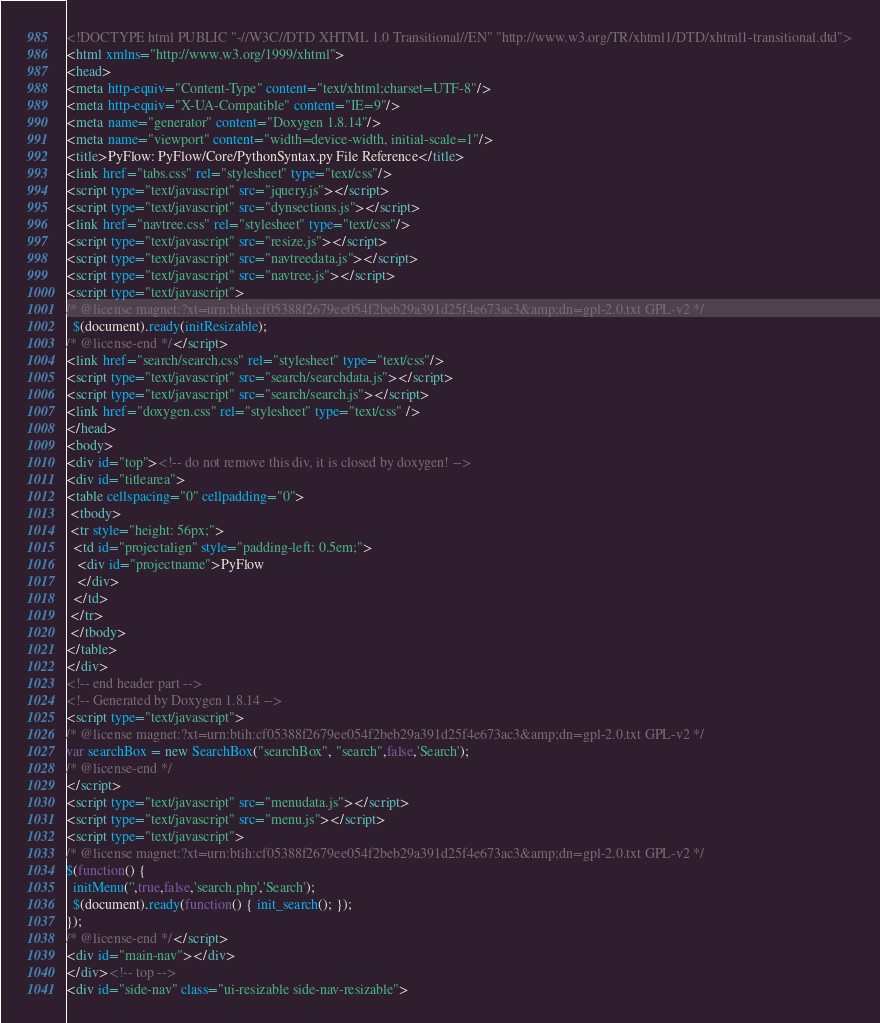<code> <loc_0><loc_0><loc_500><loc_500><_HTML_><!DOCTYPE html PUBLIC "-//W3C//DTD XHTML 1.0 Transitional//EN" "http://www.w3.org/TR/xhtml1/DTD/xhtml1-transitional.dtd">
<html xmlns="http://www.w3.org/1999/xhtml">
<head>
<meta http-equiv="Content-Type" content="text/xhtml;charset=UTF-8"/>
<meta http-equiv="X-UA-Compatible" content="IE=9"/>
<meta name="generator" content="Doxygen 1.8.14"/>
<meta name="viewport" content="width=device-width, initial-scale=1"/>
<title>PyFlow: PyFlow/Core/PythonSyntax.py File Reference</title>
<link href="tabs.css" rel="stylesheet" type="text/css"/>
<script type="text/javascript" src="jquery.js"></script>
<script type="text/javascript" src="dynsections.js"></script>
<link href="navtree.css" rel="stylesheet" type="text/css"/>
<script type="text/javascript" src="resize.js"></script>
<script type="text/javascript" src="navtreedata.js"></script>
<script type="text/javascript" src="navtree.js"></script>
<script type="text/javascript">
/* @license magnet:?xt=urn:btih:cf05388f2679ee054f2beb29a391d25f4e673ac3&amp;dn=gpl-2.0.txt GPL-v2 */
  $(document).ready(initResizable);
/* @license-end */</script>
<link href="search/search.css" rel="stylesheet" type="text/css"/>
<script type="text/javascript" src="search/searchdata.js"></script>
<script type="text/javascript" src="search/search.js"></script>
<link href="doxygen.css" rel="stylesheet" type="text/css" />
</head>
<body>
<div id="top"><!-- do not remove this div, it is closed by doxygen! -->
<div id="titlearea">
<table cellspacing="0" cellpadding="0">
 <tbody>
 <tr style="height: 56px;">
  <td id="projectalign" style="padding-left: 0.5em;">
   <div id="projectname">PyFlow
   </div>
  </td>
 </tr>
 </tbody>
</table>
</div>
<!-- end header part -->
<!-- Generated by Doxygen 1.8.14 -->
<script type="text/javascript">
/* @license magnet:?xt=urn:btih:cf05388f2679ee054f2beb29a391d25f4e673ac3&amp;dn=gpl-2.0.txt GPL-v2 */
var searchBox = new SearchBox("searchBox", "search",false,'Search');
/* @license-end */
</script>
<script type="text/javascript" src="menudata.js"></script>
<script type="text/javascript" src="menu.js"></script>
<script type="text/javascript">
/* @license magnet:?xt=urn:btih:cf05388f2679ee054f2beb29a391d25f4e673ac3&amp;dn=gpl-2.0.txt GPL-v2 */
$(function() {
  initMenu('',true,false,'search.php','Search');
  $(document).ready(function() { init_search(); });
});
/* @license-end */</script>
<div id="main-nav"></div>
</div><!-- top -->
<div id="side-nav" class="ui-resizable side-nav-resizable"></code> 